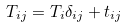Convert formula to latex. <formula><loc_0><loc_0><loc_500><loc_500>T _ { i j } = T _ { i } \delta _ { i j } + t _ { i j }</formula> 